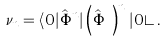<formula> <loc_0><loc_0><loc_500><loc_500>\nu _ { n } = \langle 0 | \hat { \Phi } ^ { n } | \left ( \hat { \Phi } ^ { \dagger } \right ) ^ { n } | 0 \rangle \, .</formula> 